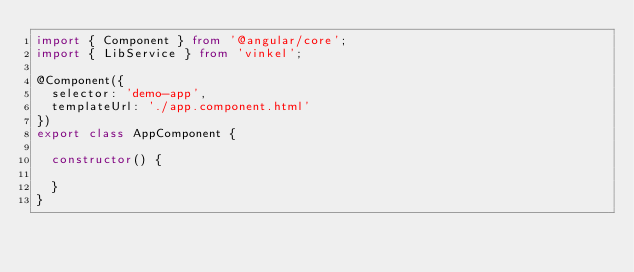<code> <loc_0><loc_0><loc_500><loc_500><_TypeScript_>import { Component } from '@angular/core';
import { LibService } from 'vinkel';

@Component({
  selector: 'demo-app',
  templateUrl: './app.component.html'
})
export class AppComponent {

  constructor() {

  }
}
</code> 